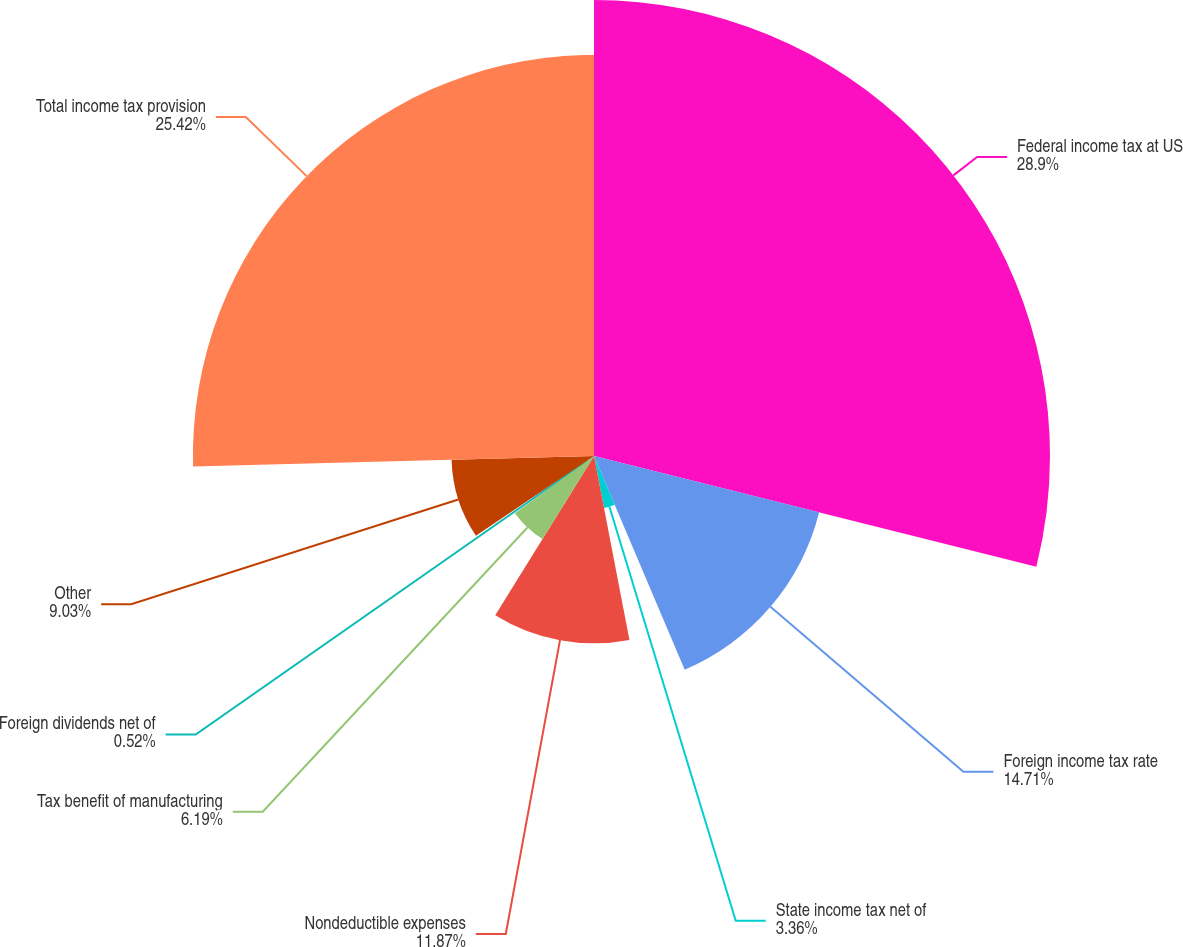<chart> <loc_0><loc_0><loc_500><loc_500><pie_chart><fcel>Federal income tax at US<fcel>Foreign income tax rate<fcel>State income tax net of<fcel>Nondeductible expenses<fcel>Tax benefit of manufacturing<fcel>Foreign dividends net of<fcel>Other<fcel>Total income tax provision<nl><fcel>28.9%<fcel>14.71%<fcel>3.36%<fcel>11.87%<fcel>6.19%<fcel>0.52%<fcel>9.03%<fcel>25.42%<nl></chart> 